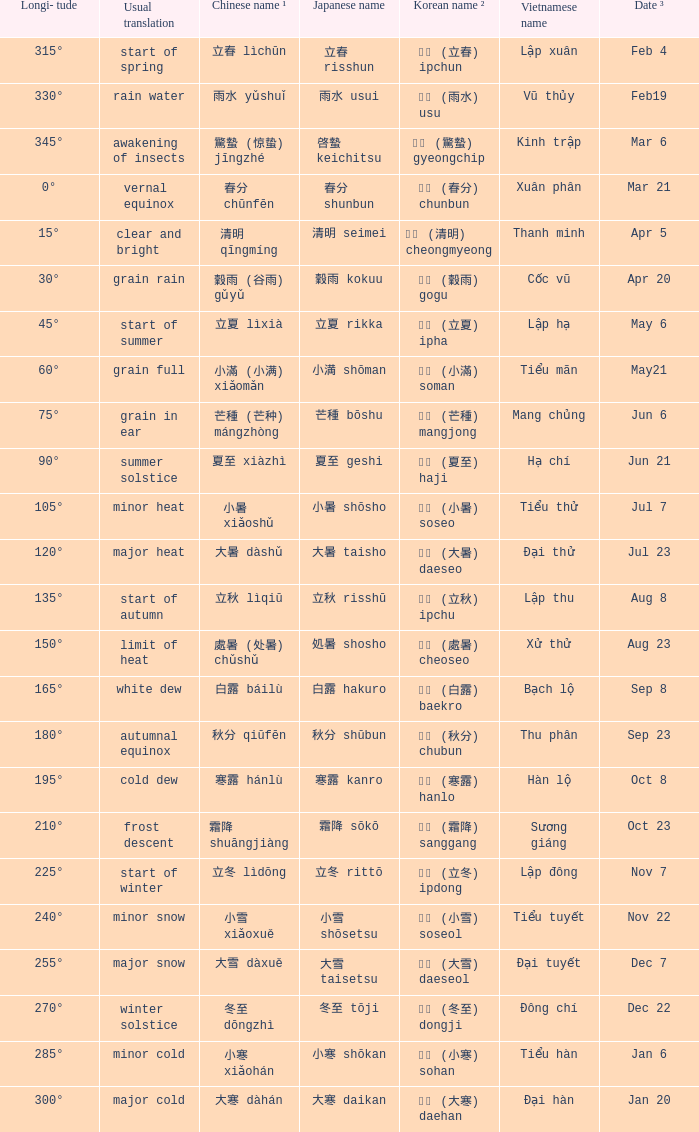Which Longi- tude is on jun 6? 75°. 